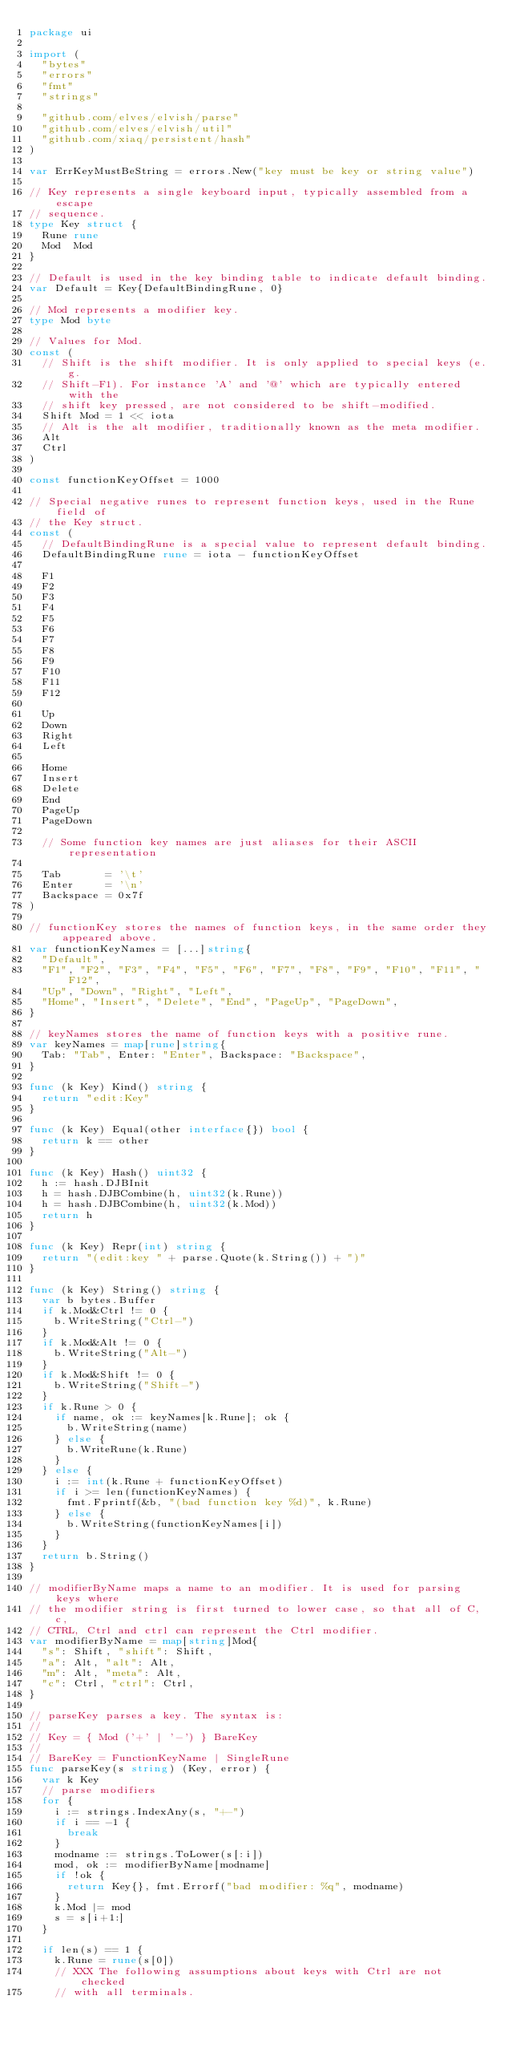Convert code to text. <code><loc_0><loc_0><loc_500><loc_500><_Go_>package ui

import (
	"bytes"
	"errors"
	"fmt"
	"strings"

	"github.com/elves/elvish/parse"
	"github.com/elves/elvish/util"
	"github.com/xiaq/persistent/hash"
)

var ErrKeyMustBeString = errors.New("key must be key or string value")

// Key represents a single keyboard input, typically assembled from a escape
// sequence.
type Key struct {
	Rune rune
	Mod  Mod
}

// Default is used in the key binding table to indicate default binding.
var Default = Key{DefaultBindingRune, 0}

// Mod represents a modifier key.
type Mod byte

// Values for Mod.
const (
	// Shift is the shift modifier. It is only applied to special keys (e.g.
	// Shift-F1). For instance 'A' and '@' which are typically entered with the
	// shift key pressed, are not considered to be shift-modified.
	Shift Mod = 1 << iota
	// Alt is the alt modifier, traditionally known as the meta modifier.
	Alt
	Ctrl
)

const functionKeyOffset = 1000

// Special negative runes to represent function keys, used in the Rune field of
// the Key struct.
const (
	// DefaultBindingRune is a special value to represent default binding.
	DefaultBindingRune rune = iota - functionKeyOffset

	F1
	F2
	F3
	F4
	F5
	F6
	F7
	F8
	F9
	F10
	F11
	F12

	Up
	Down
	Right
	Left

	Home
	Insert
	Delete
	End
	PageUp
	PageDown

	// Some function key names are just aliases for their ASCII representation

	Tab       = '\t'
	Enter     = '\n'
	Backspace = 0x7f
)

// functionKey stores the names of function keys, in the same order they appeared above.
var functionKeyNames = [...]string{
	"Default",
	"F1", "F2", "F3", "F4", "F5", "F6", "F7", "F8", "F9", "F10", "F11", "F12",
	"Up", "Down", "Right", "Left",
	"Home", "Insert", "Delete", "End", "PageUp", "PageDown",
}

// keyNames stores the name of function keys with a positive rune.
var keyNames = map[rune]string{
	Tab: "Tab", Enter: "Enter", Backspace: "Backspace",
}

func (k Key) Kind() string {
	return "edit:Key"
}

func (k Key) Equal(other interface{}) bool {
	return k == other
}

func (k Key) Hash() uint32 {
	h := hash.DJBInit
	h = hash.DJBCombine(h, uint32(k.Rune))
	h = hash.DJBCombine(h, uint32(k.Mod))
	return h
}

func (k Key) Repr(int) string {
	return "(edit:key " + parse.Quote(k.String()) + ")"
}

func (k Key) String() string {
	var b bytes.Buffer
	if k.Mod&Ctrl != 0 {
		b.WriteString("Ctrl-")
	}
	if k.Mod&Alt != 0 {
		b.WriteString("Alt-")
	}
	if k.Mod&Shift != 0 {
		b.WriteString("Shift-")
	}
	if k.Rune > 0 {
		if name, ok := keyNames[k.Rune]; ok {
			b.WriteString(name)
		} else {
			b.WriteRune(k.Rune)
		}
	} else {
		i := int(k.Rune + functionKeyOffset)
		if i >= len(functionKeyNames) {
			fmt.Fprintf(&b, "(bad function key %d)", k.Rune)
		} else {
			b.WriteString(functionKeyNames[i])
		}
	}
	return b.String()
}

// modifierByName maps a name to an modifier. It is used for parsing keys where
// the modifier string is first turned to lower case, so that all of C, c,
// CTRL, Ctrl and ctrl can represent the Ctrl modifier.
var modifierByName = map[string]Mod{
	"s": Shift, "shift": Shift,
	"a": Alt, "alt": Alt,
	"m": Alt, "meta": Alt,
	"c": Ctrl, "ctrl": Ctrl,
}

// parseKey parses a key. The syntax is:
//
// Key = { Mod ('+' | '-') } BareKey
//
// BareKey = FunctionKeyName | SingleRune
func parseKey(s string) (Key, error) {
	var k Key
	// parse modifiers
	for {
		i := strings.IndexAny(s, "+-")
		if i == -1 {
			break
		}
		modname := strings.ToLower(s[:i])
		mod, ok := modifierByName[modname]
		if !ok {
			return Key{}, fmt.Errorf("bad modifier: %q", modname)
		}
		k.Mod |= mod
		s = s[i+1:]
	}

	if len(s) == 1 {
		k.Rune = rune(s[0])
		// XXX The following assumptions about keys with Ctrl are not checked
		// with all terminals.</code> 